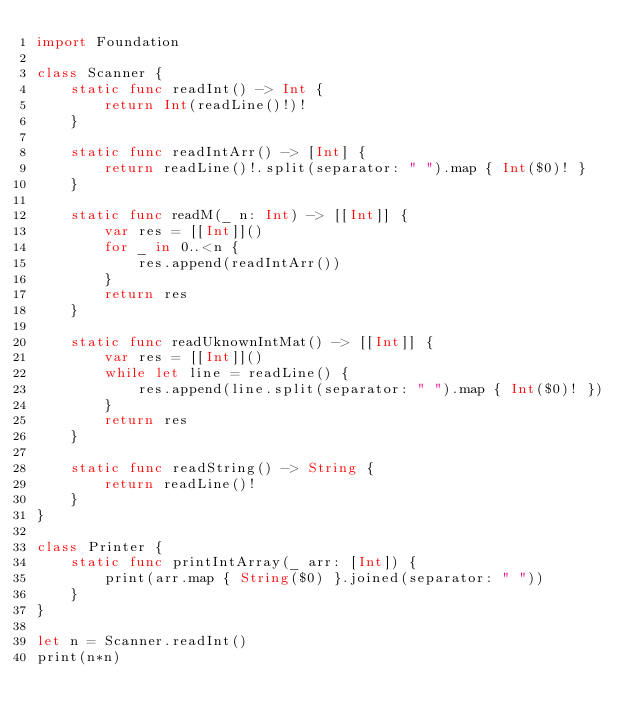Convert code to text. <code><loc_0><loc_0><loc_500><loc_500><_Swift_>import Foundation

class Scanner {
    static func readInt() -> Int {
        return Int(readLine()!)!
    }
    
    static func readIntArr() -> [Int] {
        return readLine()!.split(separator: " ").map { Int($0)! }
    }
    
    static func readM(_ n: Int) -> [[Int]] {
        var res = [[Int]]()
        for _ in 0..<n {
            res.append(readIntArr())
        }
        return res
    }
    
    static func readUknownIntMat() -> [[Int]] {
        var res = [[Int]]()
        while let line = readLine() {
            res.append(line.split(separator: " ").map { Int($0)! })
        }
        return res
    }
    
    static func readString() -> String {
        return readLine()!
    }
}

class Printer {
    static func printIntArray(_ arr: [Int]) {
        print(arr.map { String($0) }.joined(separator: " "))
    }
}

let n = Scanner.readInt()
print(n*n)
</code> 